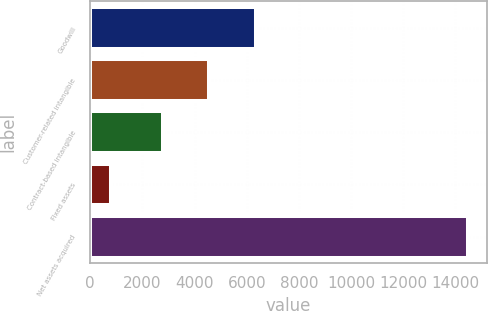Convert chart. <chart><loc_0><loc_0><loc_500><loc_500><bar_chart><fcel>Goodwill<fcel>Customer-related intangible<fcel>Contract-based intangible<fcel>Fixed assets<fcel>Net assets acquired<nl><fcel>6341<fcel>4543<fcel>2796<fcel>798<fcel>14478<nl></chart> 